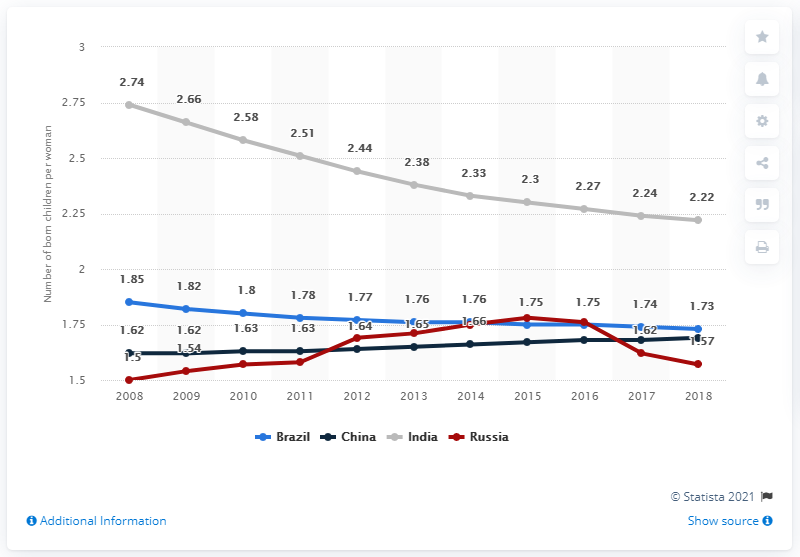Identify some key points in this picture. In 2018, the fertility rate in Brazil was 1.73. 